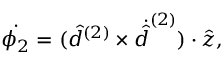Convert formula to latex. <formula><loc_0><loc_0><loc_500><loc_500>\dot { \phi _ { 2 } } = ( \hat { d } ^ { ( 2 ) } \times \dot { \hat { d } } ^ { ( 2 ) } ) \cdot \hat { z } ,</formula> 